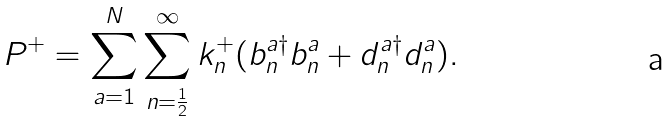<formula> <loc_0><loc_0><loc_500><loc_500>P ^ { + } = \sum _ { a = 1 } ^ { N } \sum _ { n = \frac { 1 } { 2 } } ^ { \infty } k _ { n } ^ { + } ( b _ { n } ^ { a \dag } b _ { n } ^ { a } + d _ { n } ^ { a \dag } d _ { n } ^ { a } ) .</formula> 